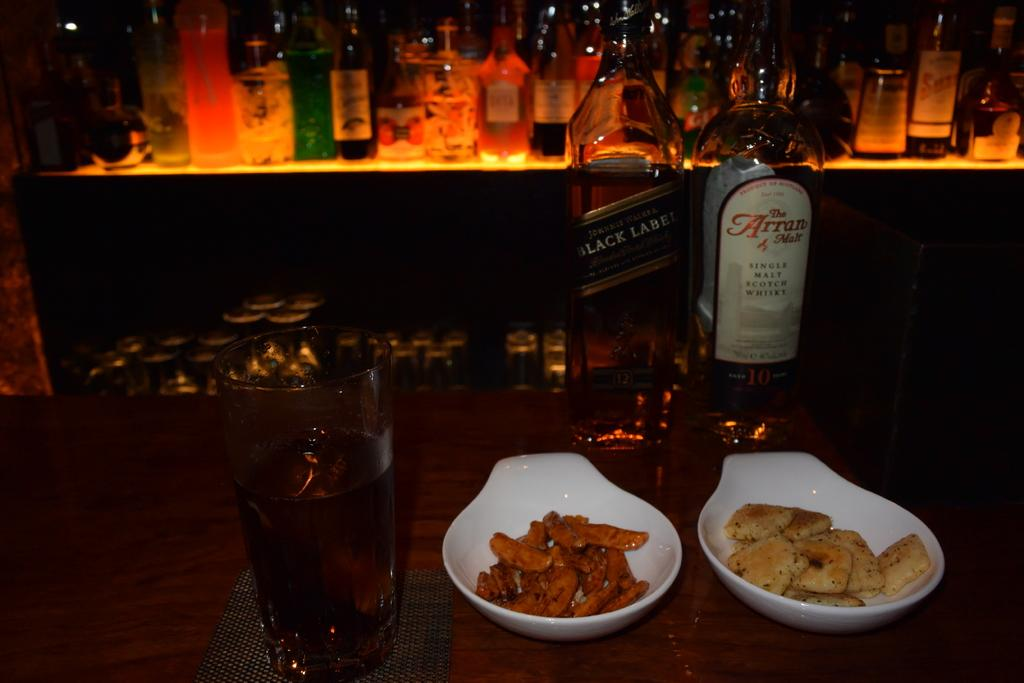<image>
Describe the image concisely. A bottle of black label and another of Arran malt sit behind bowls of food. 